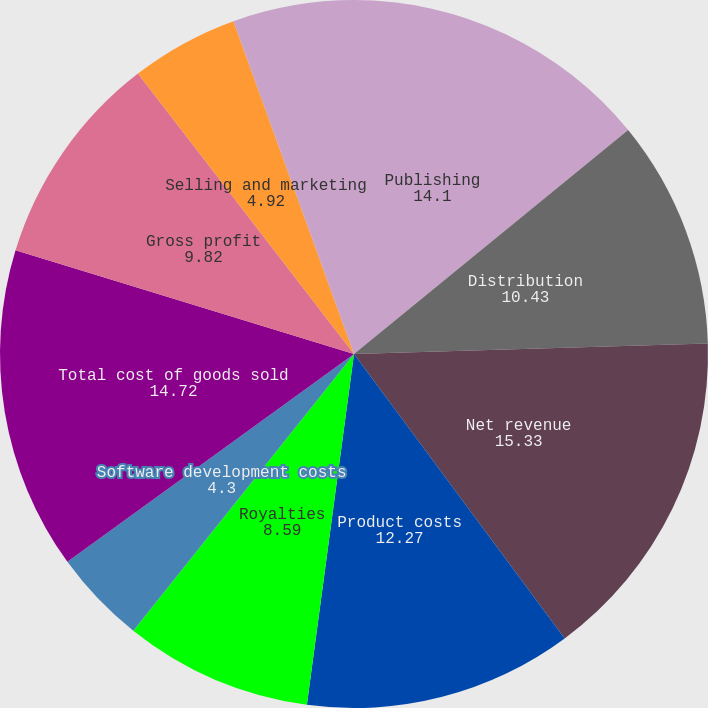<chart> <loc_0><loc_0><loc_500><loc_500><pie_chart><fcel>Publishing<fcel>Distribution<fcel>Net revenue<fcel>Product costs<fcel>Royalties<fcel>Software development costs<fcel>Total cost of goods sold<fcel>Gross profit<fcel>Selling and marketing<fcel>General and administrative<nl><fcel>14.1%<fcel>10.43%<fcel>15.33%<fcel>12.27%<fcel>8.59%<fcel>4.3%<fcel>14.72%<fcel>9.82%<fcel>4.92%<fcel>5.53%<nl></chart> 